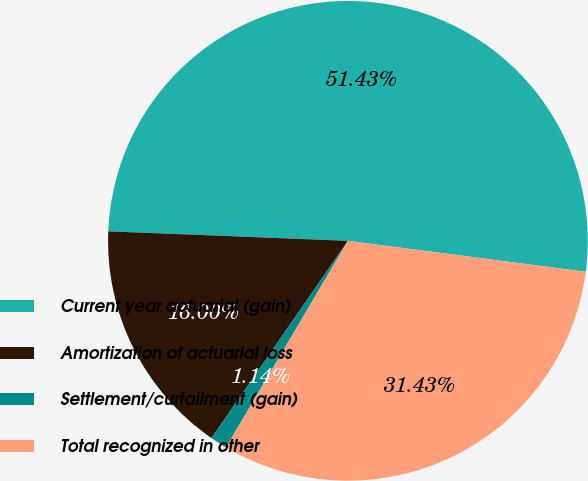<chart> <loc_0><loc_0><loc_500><loc_500><pie_chart><fcel>Current year actuarial (gain)<fcel>Amortization of actuarial loss<fcel>Settlement/curtailment (gain)<fcel>Total recognized in other<nl><fcel>51.43%<fcel>16.0%<fcel>1.14%<fcel>31.43%<nl></chart> 